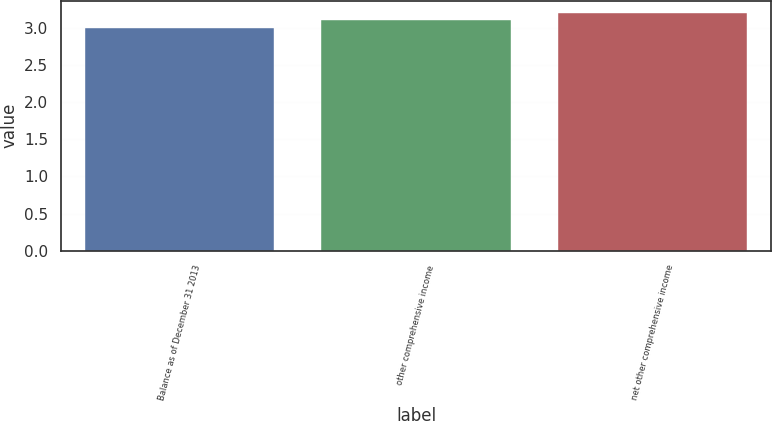Convert chart. <chart><loc_0><loc_0><loc_500><loc_500><bar_chart><fcel>Balance as of December 31 2013<fcel>other comprehensive income<fcel>net other comprehensive income<nl><fcel>3<fcel>3.1<fcel>3.2<nl></chart> 